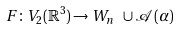Convert formula to latex. <formula><loc_0><loc_0><loc_500><loc_500>F \colon V _ { 2 } ( \mathbb { R } ^ { 3 } ) \rightarrow W _ { n } \ \cup \mathcal { A } ( \alpha )</formula> 